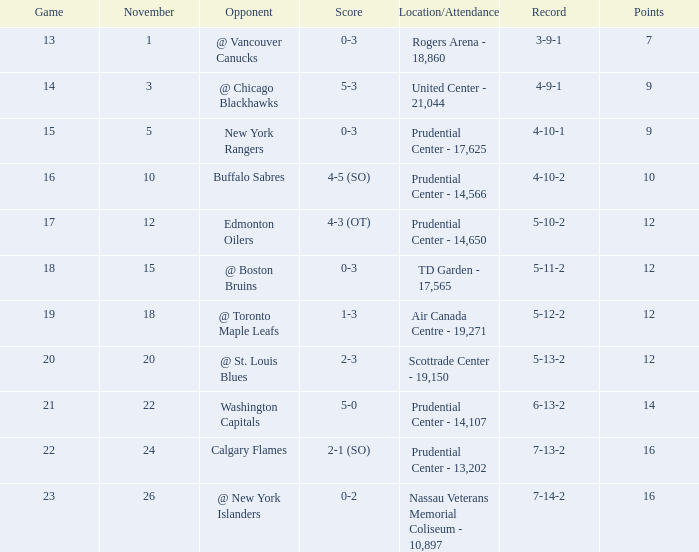What is the maximum number of points? 16.0. 